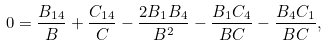<formula> <loc_0><loc_0><loc_500><loc_500>0 = \frac { B _ { 1 4 } } { B } + \frac { C _ { 1 4 } } { C } - \frac { 2 B _ { 1 } B _ { 4 } } { B ^ { 2 } } - \frac { B _ { 1 } C _ { 4 } } { B C } - \frac { B _ { 4 } C _ { 1 } } { B C } ,</formula> 